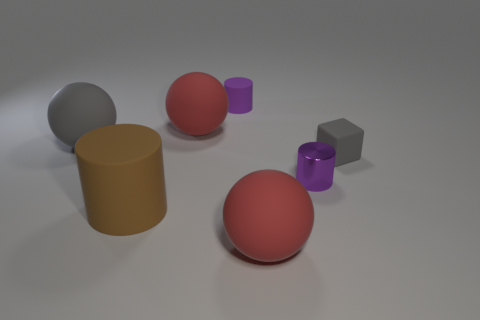Add 1 large cyan rubber spheres. How many objects exist? 8 Subtract all cylinders. How many objects are left? 4 Add 3 small purple matte things. How many small purple matte things are left? 4 Add 3 tiny rubber cubes. How many tiny rubber cubes exist? 4 Subtract 0 red cubes. How many objects are left? 7 Subtract all gray matte cubes. Subtract all brown matte cylinders. How many objects are left? 5 